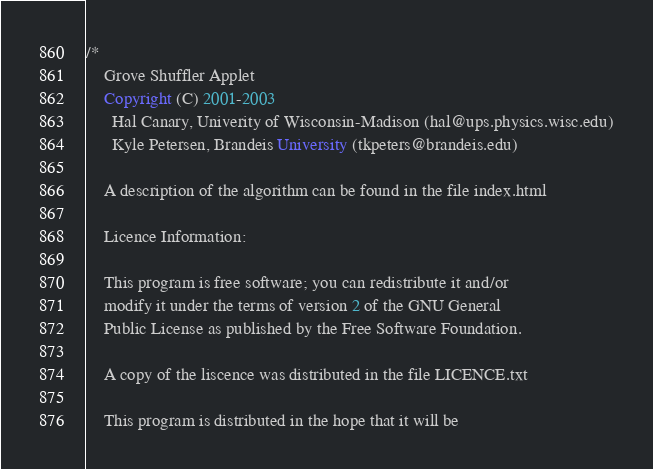<code> <loc_0><loc_0><loc_500><loc_500><_Java_>/*
    Grove Shuffler Applet
    Copyright (C) 2001-2003  
      Hal Canary, Univerity of Wisconsin-Madison (hal@ups.physics.wisc.edu)
      Kyle Petersen, Brandeis University (tkpeters@brandeis.edu)

    A description of the algorithm can be found in the file index.html

    Licence Information:

	This program is free software; you can redistribute it and/or
	modify it under the terms of version 2 of the GNU General
	Public License as published by the Free Software Foundation.

	A copy of the liscence was distributed in the file LICENCE.txt

	This program is distributed in the hope that it will be</code> 